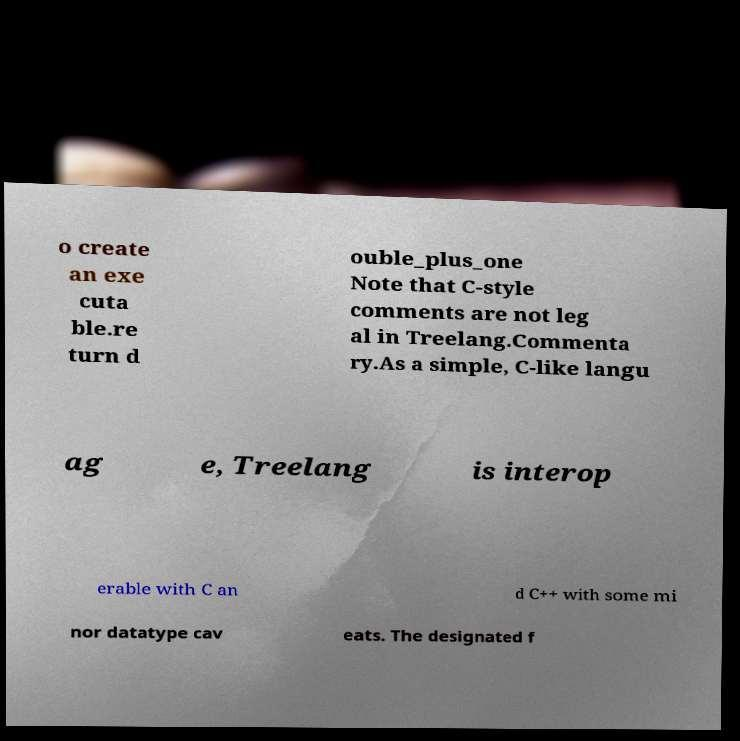Can you accurately transcribe the text from the provided image for me? o create an exe cuta ble.re turn d ouble_plus_one Note that C-style comments are not leg al in Treelang.Commenta ry.As a simple, C-like langu ag e, Treelang is interop erable with C an d C++ with some mi nor datatype cav eats. The designated f 